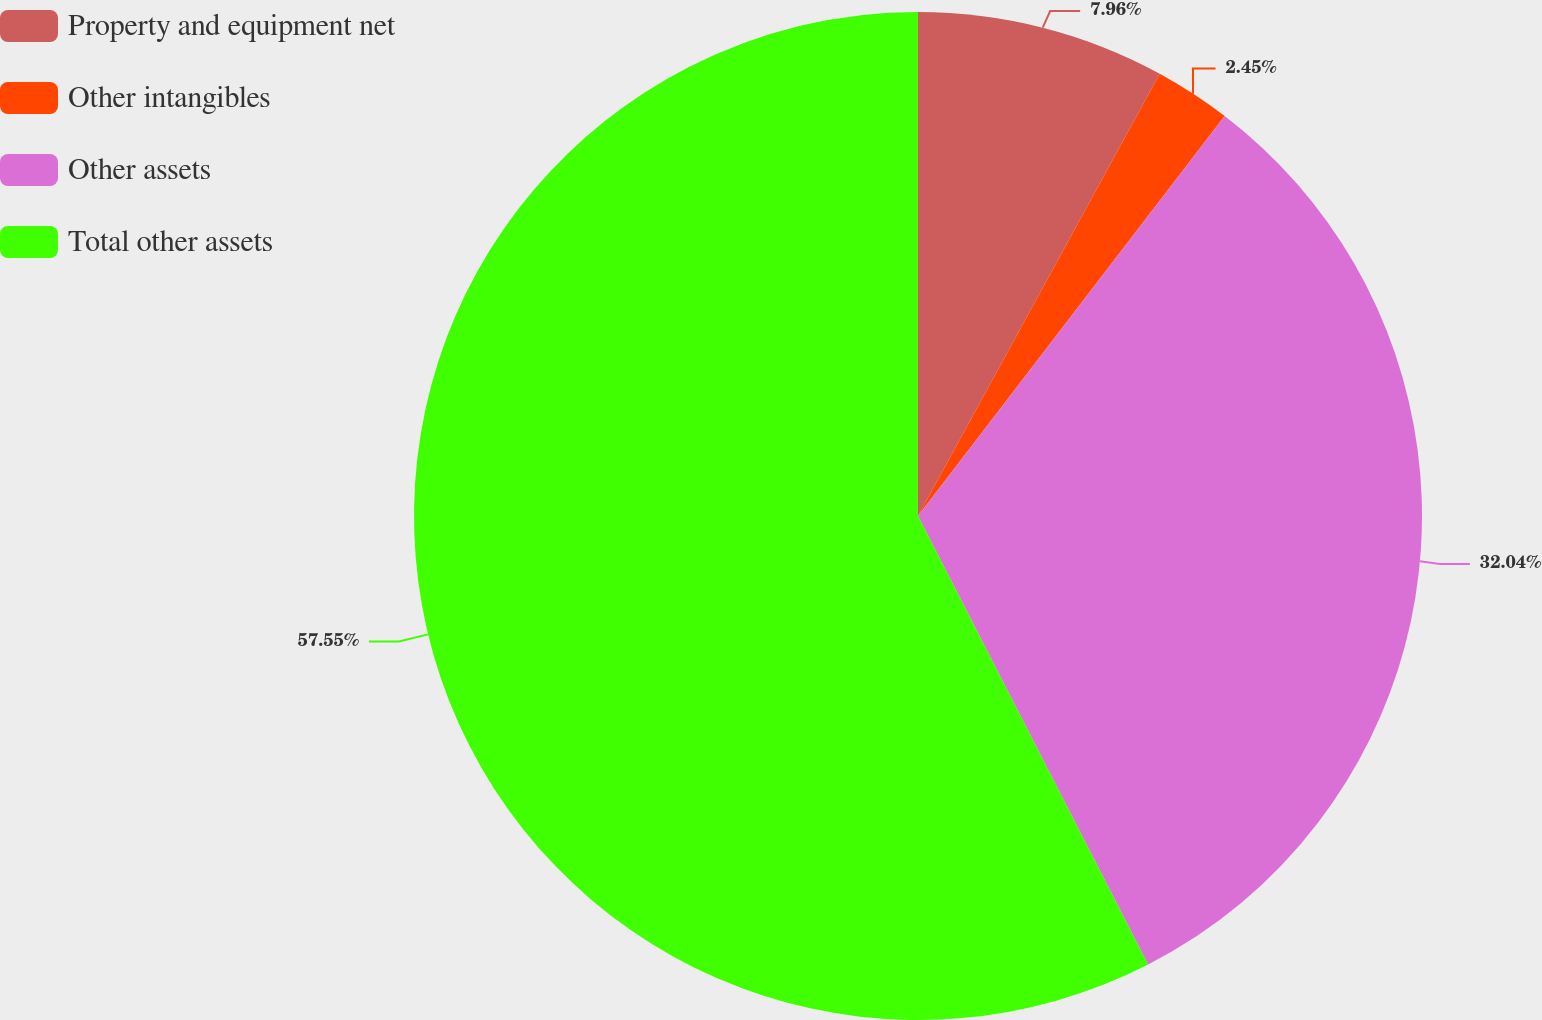Convert chart. <chart><loc_0><loc_0><loc_500><loc_500><pie_chart><fcel>Property and equipment net<fcel>Other intangibles<fcel>Other assets<fcel>Total other assets<nl><fcel>7.96%<fcel>2.45%<fcel>32.04%<fcel>57.54%<nl></chart> 